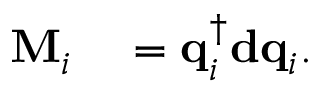Convert formula to latex. <formula><loc_0><loc_0><loc_500><loc_500>\begin{array} { r l } { M _ { i } } & = q _ { i } ^ { \dagger } d q _ { i } . } \end{array}</formula> 